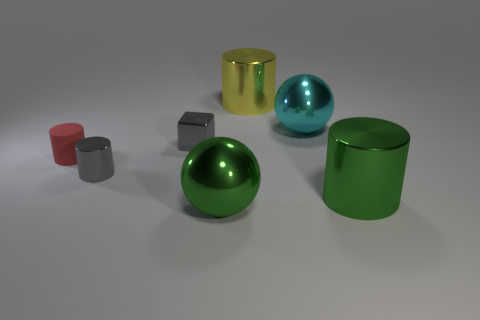Subtract all matte cylinders. How many cylinders are left? 3 Subtract all yellow cylinders. How many cylinders are left? 3 Subtract 1 blocks. How many blocks are left? 0 Subtract all cubes. How many objects are left? 6 Add 2 cylinders. How many objects exist? 9 Subtract 0 red balls. How many objects are left? 7 Subtract all brown spheres. Subtract all blue cylinders. How many spheres are left? 2 Subtract all small gray cylinders. Subtract all tiny cubes. How many objects are left? 5 Add 1 large green cylinders. How many large green cylinders are left? 2 Add 3 rubber blocks. How many rubber blocks exist? 3 